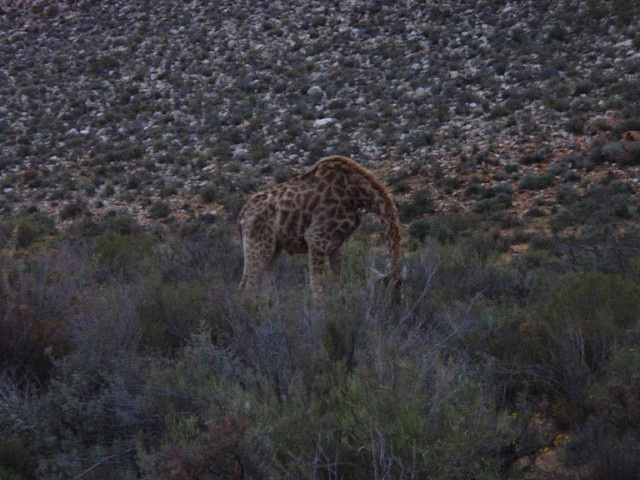Describe the objects in this image and their specific colors. I can see a giraffe in purple, black, and gray tones in this image. 